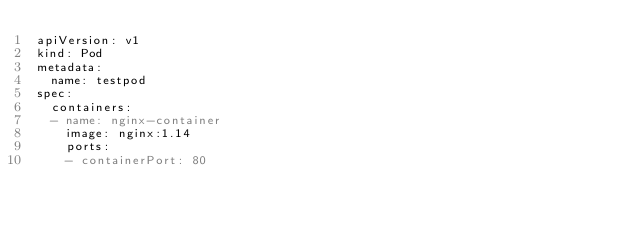Convert code to text. <code><loc_0><loc_0><loc_500><loc_500><_YAML_>apiVersion: v1
kind: Pod
metadata:
  name: testpod
spec:
  containers:
  - name: nginx-container
    image: nginx:1.14
    ports:
    - containerPort: 80
</code> 